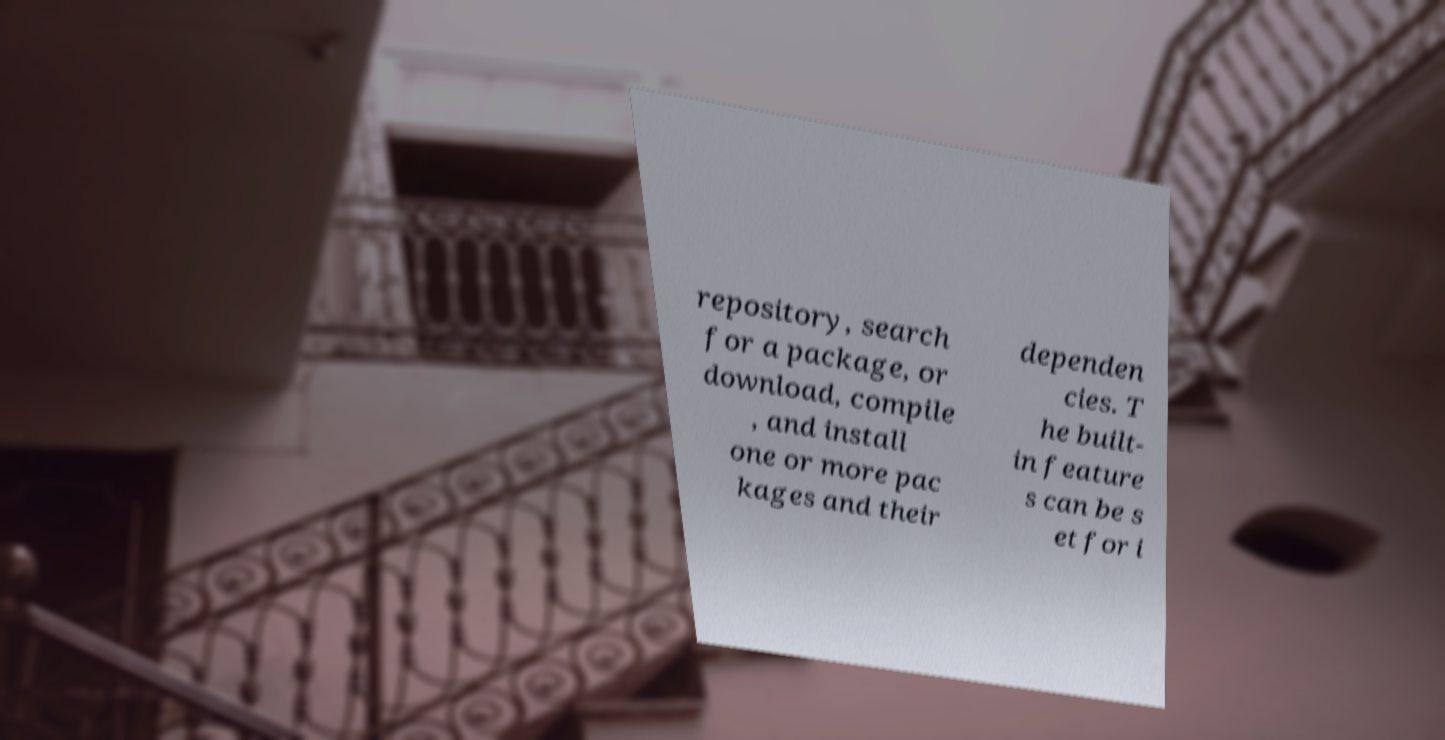I need the written content from this picture converted into text. Can you do that? repository, search for a package, or download, compile , and install one or more pac kages and their dependen cies. T he built- in feature s can be s et for i 